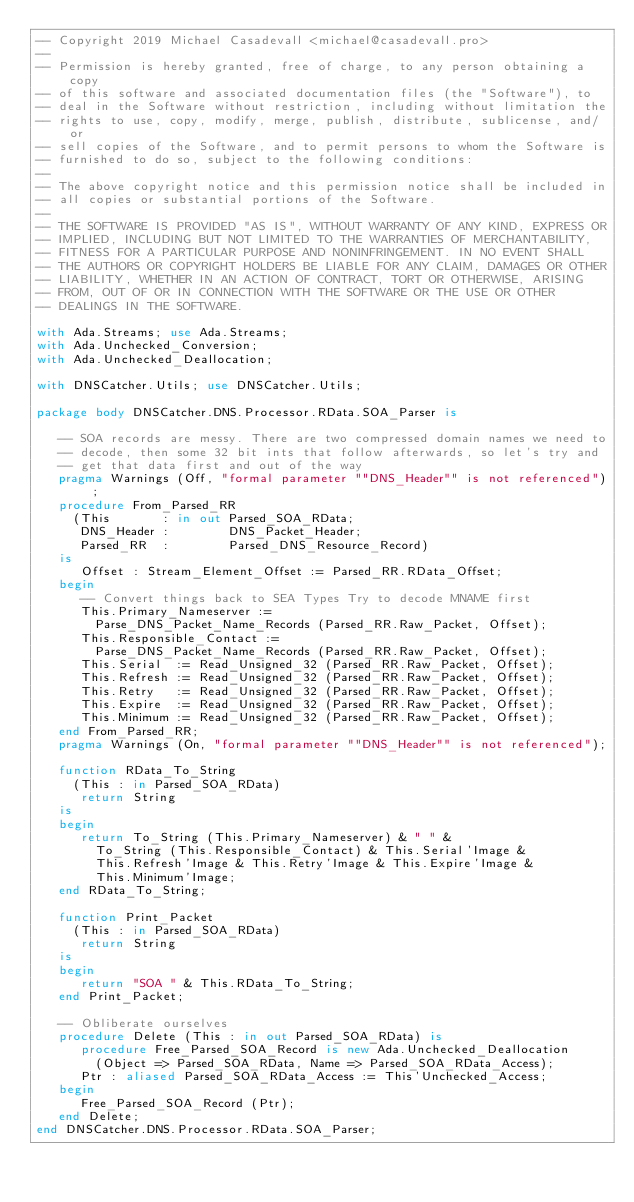<code> <loc_0><loc_0><loc_500><loc_500><_Ada_>-- Copyright 2019 Michael Casadevall <michael@casadevall.pro>
--
-- Permission is hereby granted, free of charge, to any person obtaining a copy
-- of this software and associated documentation files (the "Software"), to
-- deal in the Software without restriction, including without limitation the
-- rights to use, copy, modify, merge, publish, distribute, sublicense, and/or
-- sell copies of the Software, and to permit persons to whom the Software is
-- furnished to do so, subject to the following conditions:
--
-- The above copyright notice and this permission notice shall be included in
-- all copies or substantial portions of the Software.
--
-- THE SOFTWARE IS PROVIDED "AS IS", WITHOUT WARRANTY OF ANY KIND, EXPRESS OR
-- IMPLIED, INCLUDING BUT NOT LIMITED TO THE WARRANTIES OF MERCHANTABILITY,
-- FITNESS FOR A PARTICULAR PURPOSE AND NONINFRINGEMENT. IN NO EVENT SHALL
-- THE AUTHORS OR COPYRIGHT HOLDERS BE LIABLE FOR ANY CLAIM, DAMAGES OR OTHER
-- LIABILITY, WHETHER IN AN ACTION OF CONTRACT, TORT OR OTHERWISE, ARISING
-- FROM, OUT OF OR IN CONNECTION WITH THE SOFTWARE OR THE USE OR OTHER
-- DEALINGS IN THE SOFTWARE.

with Ada.Streams; use Ada.Streams;
with Ada.Unchecked_Conversion;
with Ada.Unchecked_Deallocation;

with DNSCatcher.Utils; use DNSCatcher.Utils;

package body DNSCatcher.DNS.Processor.RData.SOA_Parser is

   -- SOA records are messy. There are two compressed domain names we need to
   -- decode, then some 32 bit ints that follow afterwards, so let's try and
   -- get that data first and out of the way
   pragma Warnings (Off, "formal parameter ""DNS_Header"" is not referenced");
   procedure From_Parsed_RR
     (This       : in out Parsed_SOA_RData;
      DNS_Header :        DNS_Packet_Header;
      Parsed_RR  :        Parsed_DNS_Resource_Record)
   is
      Offset : Stream_Element_Offset := Parsed_RR.RData_Offset;
   begin
      -- Convert things back to SEA Types Try to decode MNAME first
      This.Primary_Nameserver :=
        Parse_DNS_Packet_Name_Records (Parsed_RR.Raw_Packet, Offset);
      This.Responsible_Contact :=
        Parse_DNS_Packet_Name_Records (Parsed_RR.Raw_Packet, Offset);
      This.Serial  := Read_Unsigned_32 (Parsed_RR.Raw_Packet, Offset);
      This.Refresh := Read_Unsigned_32 (Parsed_RR.Raw_Packet, Offset);
      This.Retry   := Read_Unsigned_32 (Parsed_RR.Raw_Packet, Offset);
      This.Expire  := Read_Unsigned_32 (Parsed_RR.Raw_Packet, Offset);
      This.Minimum := Read_Unsigned_32 (Parsed_RR.Raw_Packet, Offset);
   end From_Parsed_RR;
   pragma Warnings (On, "formal parameter ""DNS_Header"" is not referenced");

   function RData_To_String
     (This : in Parsed_SOA_RData)
      return String
   is
   begin
      return To_String (This.Primary_Nameserver) & " " &
        To_String (This.Responsible_Contact) & This.Serial'Image &
        This.Refresh'Image & This.Retry'Image & This.Expire'Image &
        This.Minimum'Image;
   end RData_To_String;

   function Print_Packet
     (This : in Parsed_SOA_RData)
      return String
   is
   begin
      return "SOA " & This.RData_To_String;
   end Print_Packet;

   -- Obliberate ourselves
   procedure Delete (This : in out Parsed_SOA_RData) is
      procedure Free_Parsed_SOA_Record is new Ada.Unchecked_Deallocation
        (Object => Parsed_SOA_RData, Name => Parsed_SOA_RData_Access);
      Ptr : aliased Parsed_SOA_RData_Access := This'Unchecked_Access;
   begin
      Free_Parsed_SOA_Record (Ptr);
   end Delete;
end DNSCatcher.DNS.Processor.RData.SOA_Parser;
</code> 